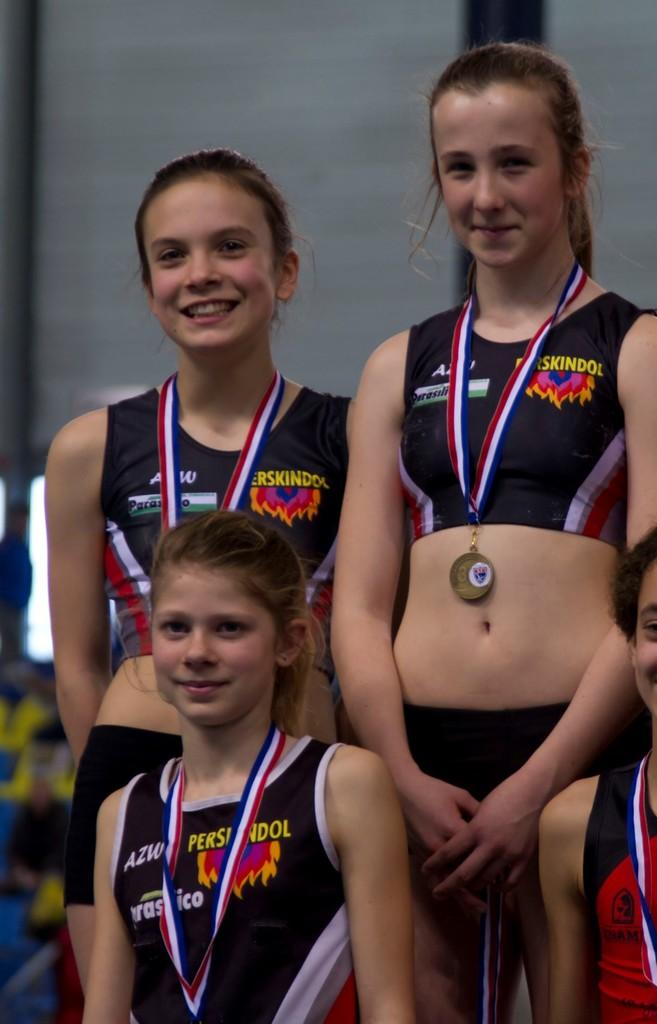<image>
Relay a brief, clear account of the picture shown. Three girls are wearing medals and their shirts say perskindol. 